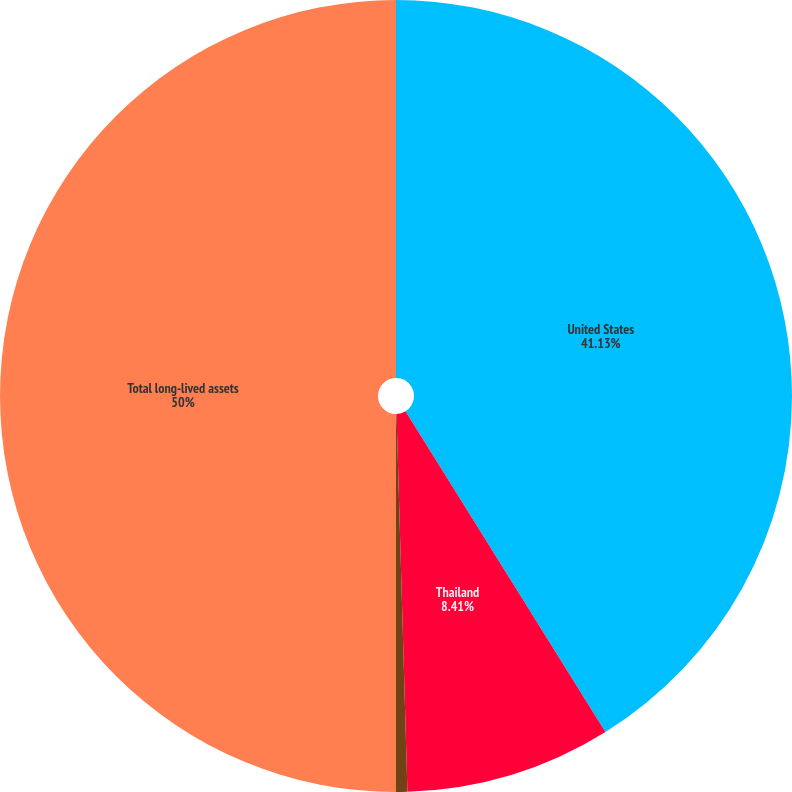Convert chart to OTSL. <chart><loc_0><loc_0><loc_500><loc_500><pie_chart><fcel>United States<fcel>Thailand<fcel>Various other countries<fcel>Total long-lived assets<nl><fcel>41.13%<fcel>8.41%<fcel>0.46%<fcel>50.0%<nl></chart> 